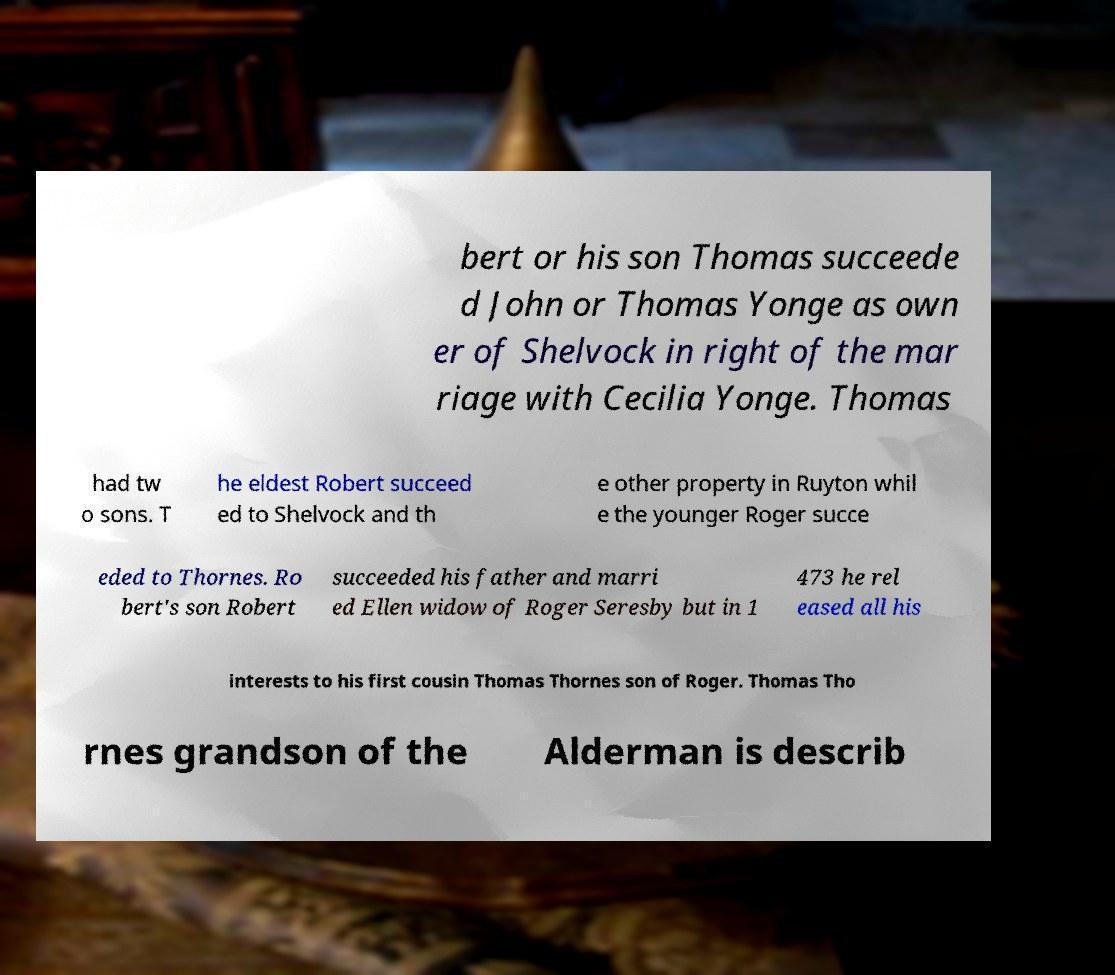Could you extract and type out the text from this image? bert or his son Thomas succeede d John or Thomas Yonge as own er of Shelvock in right of the mar riage with Cecilia Yonge. Thomas had tw o sons. T he eldest Robert succeed ed to Shelvock and th e other property in Ruyton whil e the younger Roger succe eded to Thornes. Ro bert's son Robert succeeded his father and marri ed Ellen widow of Roger Seresby but in 1 473 he rel eased all his interests to his first cousin Thomas Thornes son of Roger. Thomas Tho rnes grandson of the Alderman is describ 